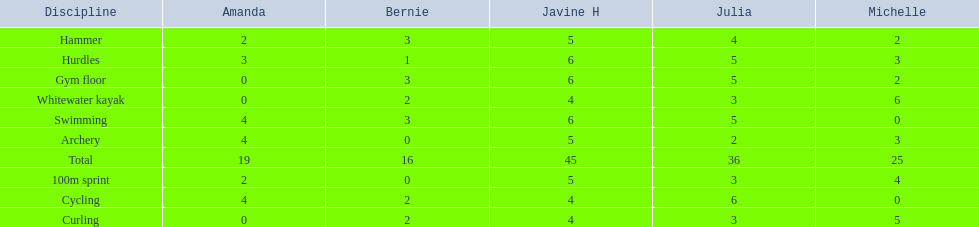Who had her best score in cycling? Julia. 